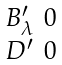<formula> <loc_0><loc_0><loc_500><loc_500>\begin{smallmatrix} B _ { \lambda } ^ { \prime } & 0 \\ D ^ { \prime } & 0 \\ \end{smallmatrix}</formula> 